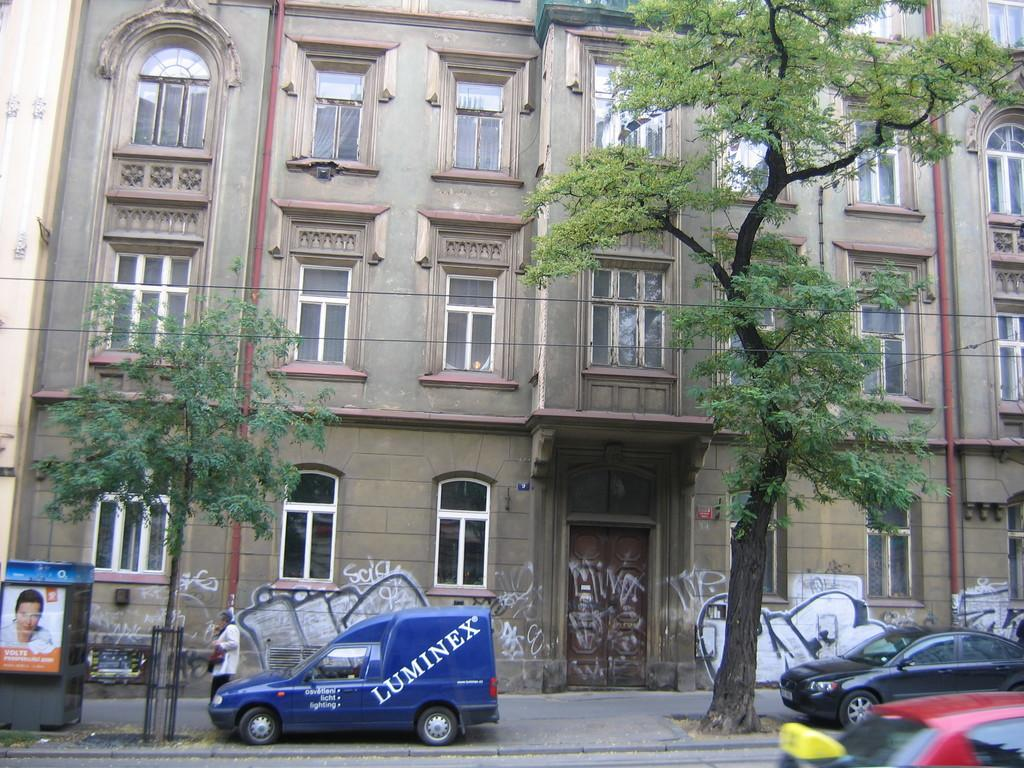<image>
Present a compact description of the photo's key features. A blue vehicle with the word LUMINEX on the side is parked in front of a building. 